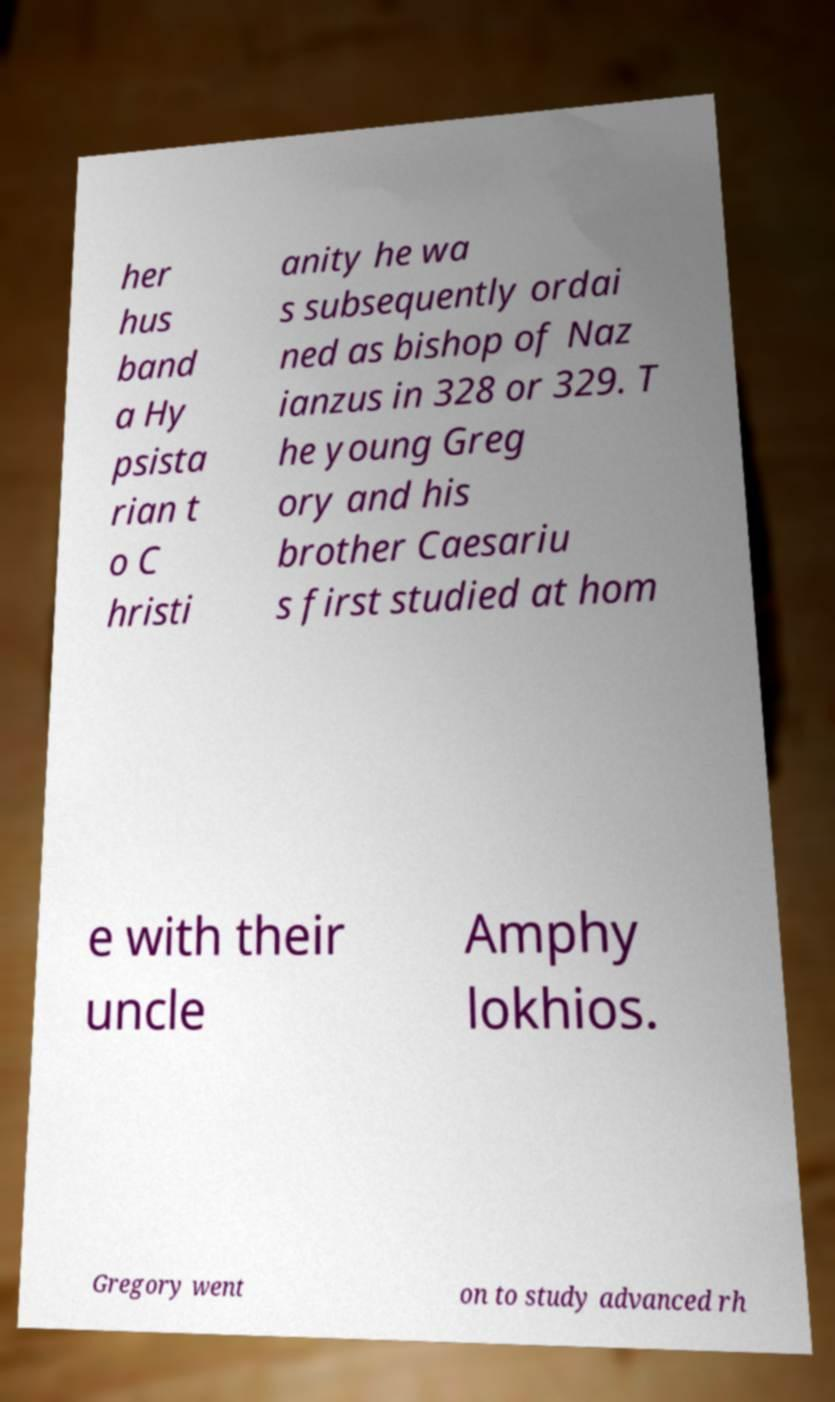Please identify and transcribe the text found in this image. her hus band a Hy psista rian t o C hristi anity he wa s subsequently ordai ned as bishop of Naz ianzus in 328 or 329. T he young Greg ory and his brother Caesariu s first studied at hom e with their uncle Amphy lokhios. Gregory went on to study advanced rh 